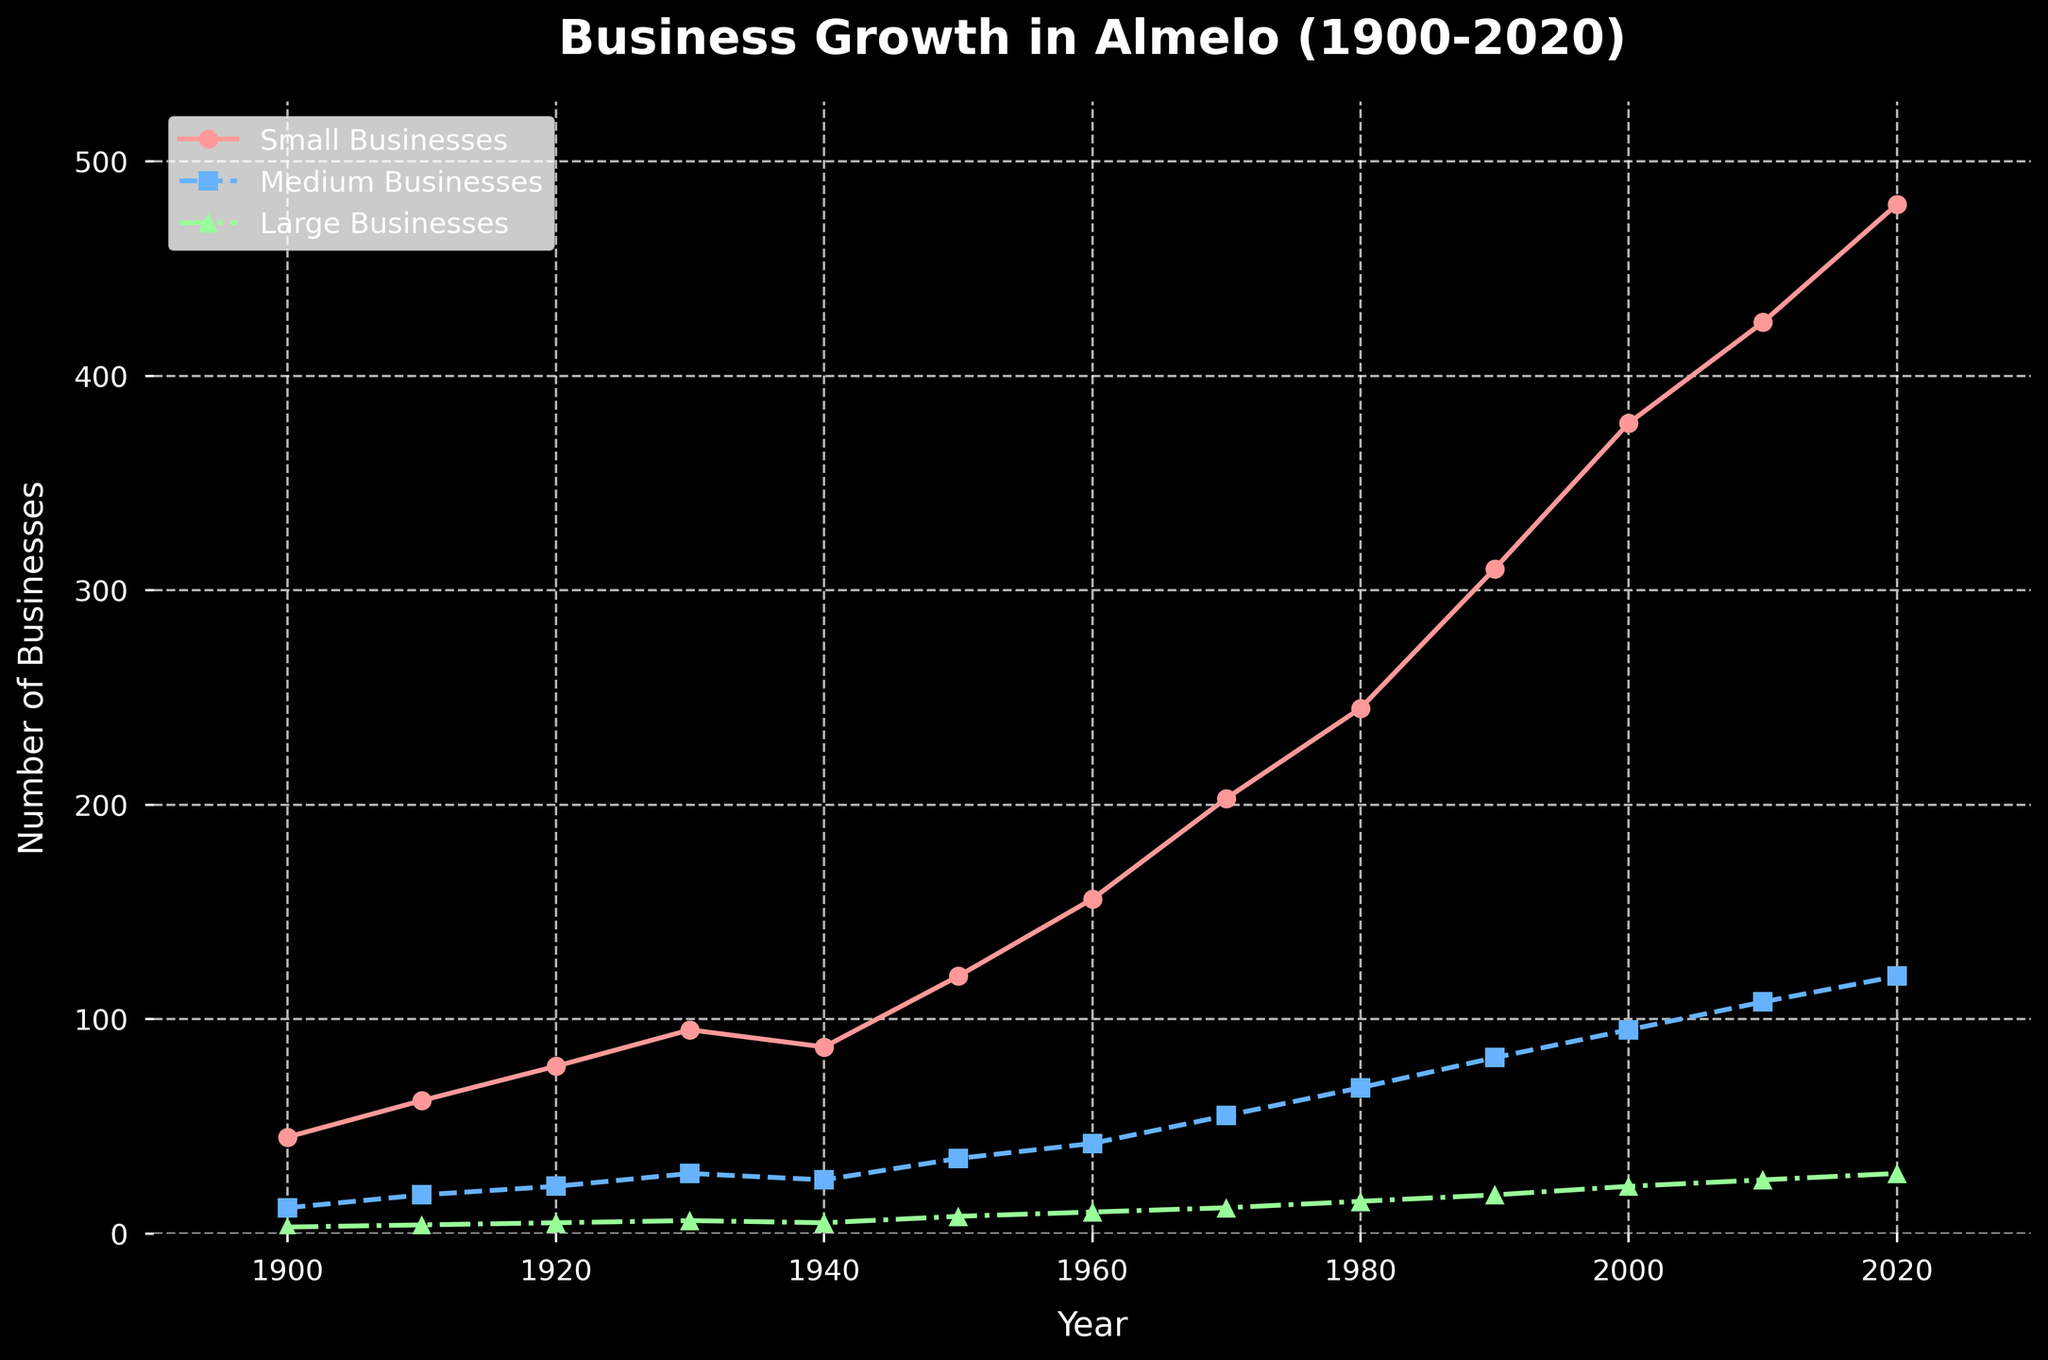Which category of businesses saw the most growth from 1900 to 2020? Look at the difference in values from 1900 to 2020 for each category. Small businesses grew from 45 to 480 (a difference of 435), medium businesses from 12 to 120 (a difference of 108), and large businesses from 3 to 28 (a difference of 25). The largest increase is for small businesses.
Answer: Small businesses How many medium businesses were there in 1980, and how does this compare to the number of large businesses in the same year? The plot shows that in 1980, there were 68 medium businesses and 15 large businesses. To compare, we subtract the number of large businesses from medium businesses: 68 - 15 = 53.
Answer: 68 medium businesses, 53 more than large businesses In which decade did small businesses experience the highest growth rate? Calculate the increase in number of small businesses for each decade and then compare these values to find the highest. The increases are: 1900-1910: 62 - 45 = 17, 1910-1920: 78 - 62 = 16, 1920-1930: 95 - 78 = 17, 1930-1940: 87 - 95 = -8, 1940-1950: 120 - 87 = 33, 1950-1960: 156 - 120 = 36, 1960-1970: 203 - 156 = 47, 1970-1980: 245 - 203 = 42, 1980-1990: 310 - 245 = 65, 1990-2000: 378 - 310 = 68, 2000-2010: 425 - 378 = 47, 2010-2020: 480 - 425 = 55. The highest growth is 68 from 1990-2000.
Answer: 1990-2000 What is the average number of large businesses registered per year during the period 1900-2020? Sum the number of large businesses for all years and divide by the number of years. Sum = 3 + 4 + 5 + 6 + 5 + 8 + 10 + 12 + 15 + 18 + 22 + 25 + 28 = 161. Number of years = 2020 - 1900 = 120 + 1 = 121. Average = 161 / 121 ≈ 1.33 (rounded to 2 decimal places).
Answer: 1.33 Which decade saw a decrease in the number of small businesses? Observe the plot to identify any decade where the line for small businesses drops. From 1930 to 1940, the number of small businesses decreased from 95 to 87, indicating a decline in that decade.
Answer: 1930-1940 How did the number of medium businesses change between 1950 and 1960, and what percentage increase does this represent? In 1950, there were 35 medium businesses, and in 1960, there were 42. The change is 42 - 35 = 7. To find the percentage increase: (7 / 35) * 100% ≈ 20%.
Answer: Increased by 7, 20% How does the number of large businesses in 2020 compare to the number of small businesses in 1920? In 2020, there are 28 large businesses, and in 1920, there are 78 small businesses. Comparing them directly shows that there are fewer large businesses in 2020 than small businesses in 1920 by 78 - 28 = 50.
Answer: 50 fewer large businesses in 2020 What color represents the medium businesses on the chart? The plot uses different colors for each category: small businesses are red, medium businesses are blue, and large businesses are green.
Answer: Blue 